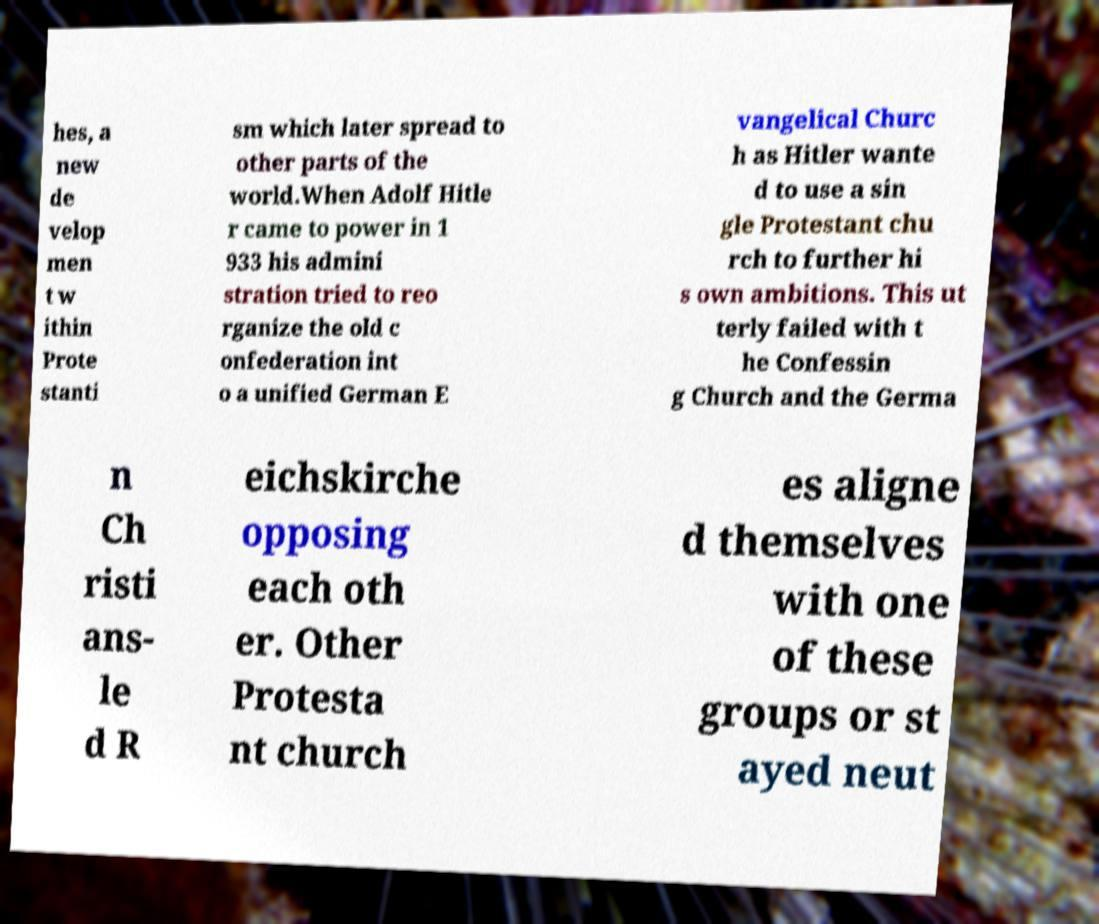I need the written content from this picture converted into text. Can you do that? hes, a new de velop men t w ithin Prote stanti sm which later spread to other parts of the world.When Adolf Hitle r came to power in 1 933 his admini stration tried to reo rganize the old c onfederation int o a unified German E vangelical Churc h as Hitler wante d to use a sin gle Protestant chu rch to further hi s own ambitions. This ut terly failed with t he Confessin g Church and the Germa n Ch risti ans- le d R eichskirche opposing each oth er. Other Protesta nt church es aligne d themselves with one of these groups or st ayed neut 